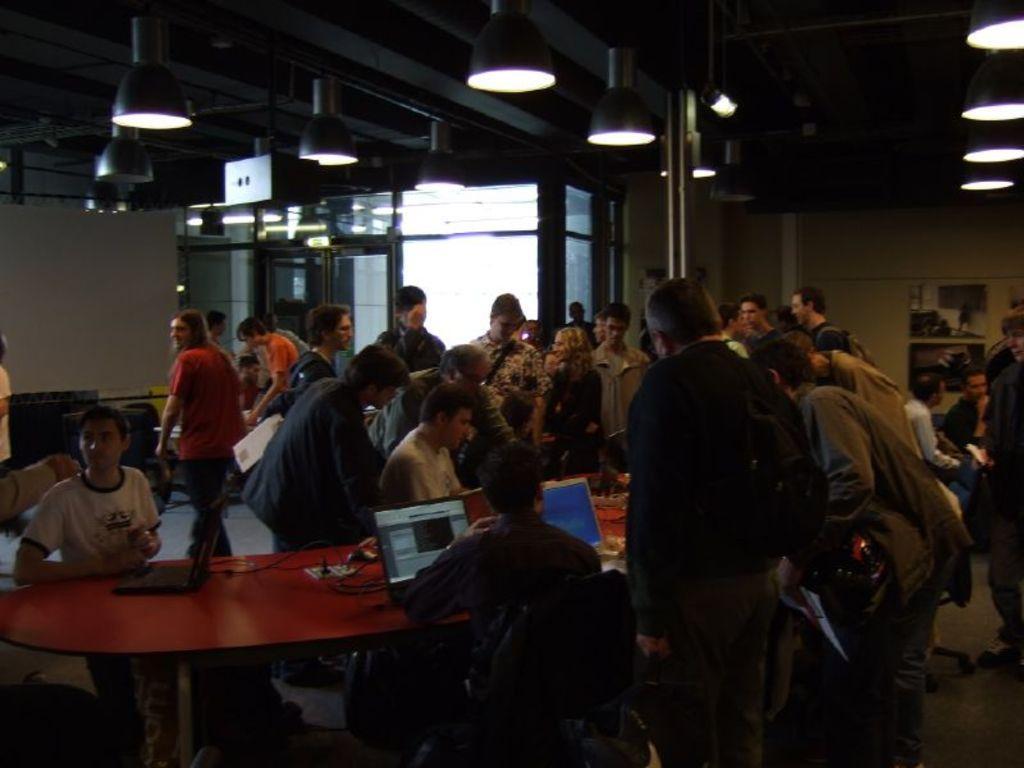Please provide a concise description of this image. There is a group of people. There is a man sitting at the center. There is a woman standing here and she is smiling. On the extreme right there are two people having a conversation. This is a table where laptops are kept on it. 